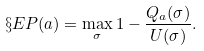Convert formula to latex. <formula><loc_0><loc_0><loc_500><loc_500>\S E P ( a ) = \max _ { \sigma } 1 - \frac { Q _ { a } ( \sigma ) } { U ( \sigma ) } .</formula> 